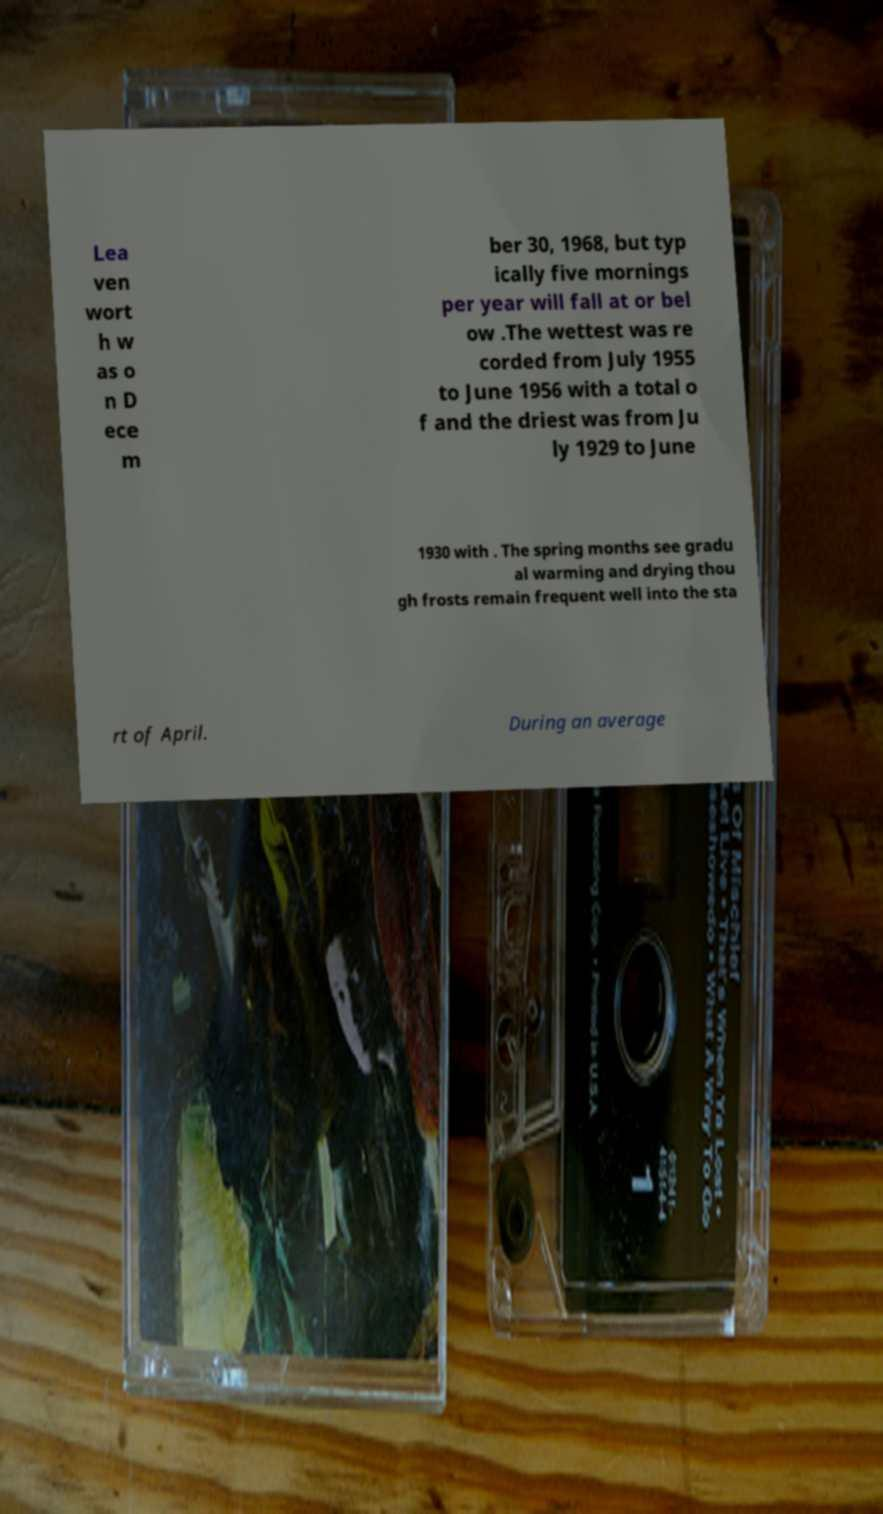There's text embedded in this image that I need extracted. Can you transcribe it verbatim? Lea ven wort h w as o n D ece m ber 30, 1968, but typ ically five mornings per year will fall at or bel ow .The wettest was re corded from July 1955 to June 1956 with a total o f and the driest was from Ju ly 1929 to June 1930 with . The spring months see gradu al warming and drying thou gh frosts remain frequent well into the sta rt of April. During an average 